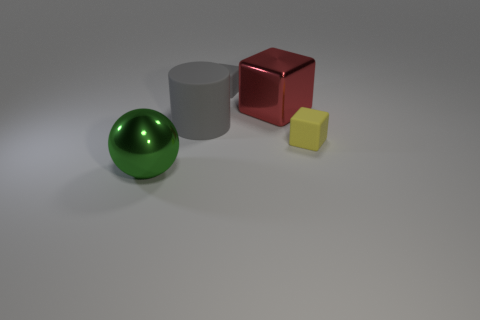There is another big thing that is the same shape as the yellow rubber thing; what color is it?
Keep it short and to the point. Red. There is a gray matte thing that is the same shape as the red object; what size is it?
Provide a succinct answer. Small. Do the matte cube that is in front of the large gray matte thing and the metallic object on the left side of the large red shiny thing have the same size?
Offer a terse response. No. The tiny rubber object that is to the left of the big shiny object on the right side of the large gray cylinder is what shape?
Make the answer very short. Cube. How many big rubber cylinders are in front of the large green metallic sphere?
Provide a short and direct response. 0. The tiny thing that is made of the same material as the yellow block is what color?
Your response must be concise. Gray. Do the red object and the gray object to the right of the rubber cylinder have the same size?
Your response must be concise. No. How big is the metal thing that is behind the large metal thing on the left side of the matte object behind the red thing?
Your response must be concise. Large. What number of matte objects are either objects or small gray objects?
Give a very brief answer. 3. The small block in front of the large red object is what color?
Your answer should be compact. Yellow. 